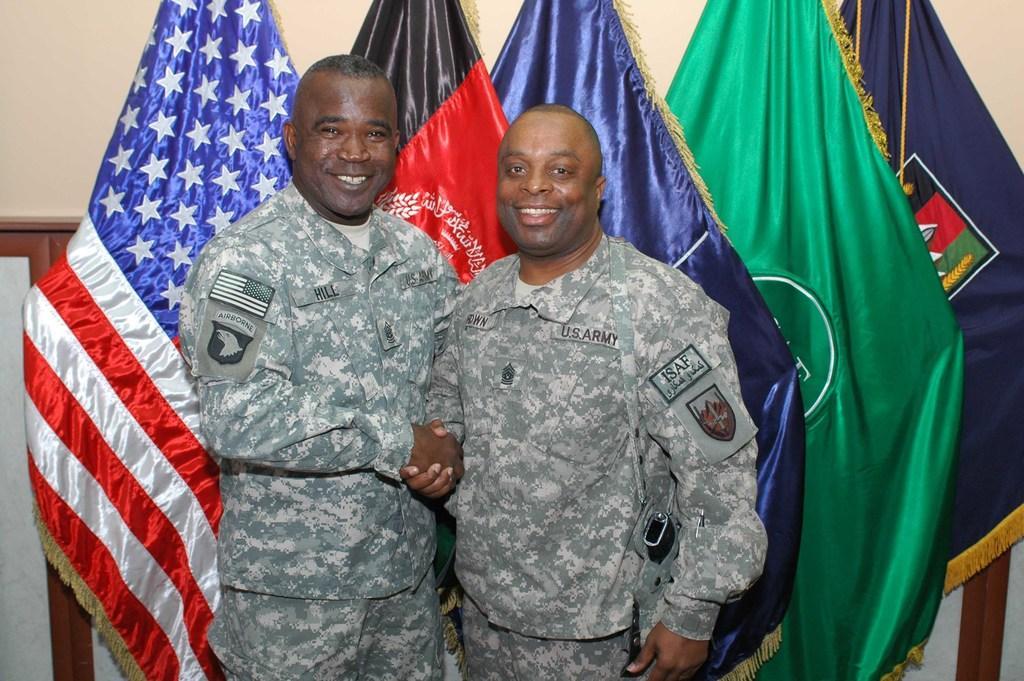Describe this image in one or two sentences. In this image in the center there are persons standing and smiling and shaking hands with each other. In the background there are flags and there is wall. 